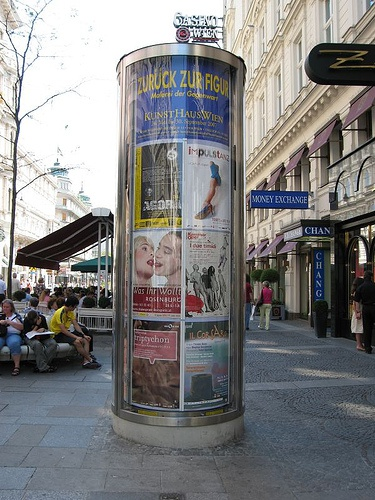Describe the objects in this image and their specific colors. I can see people in lightgray, black, gray, and darkgray tones, people in lightgray, black, olive, and gray tones, people in lightgray, black, gray, and purple tones, people in lightgray, black, gray, navy, and maroon tones, and people in lightgray, black, and gray tones in this image. 